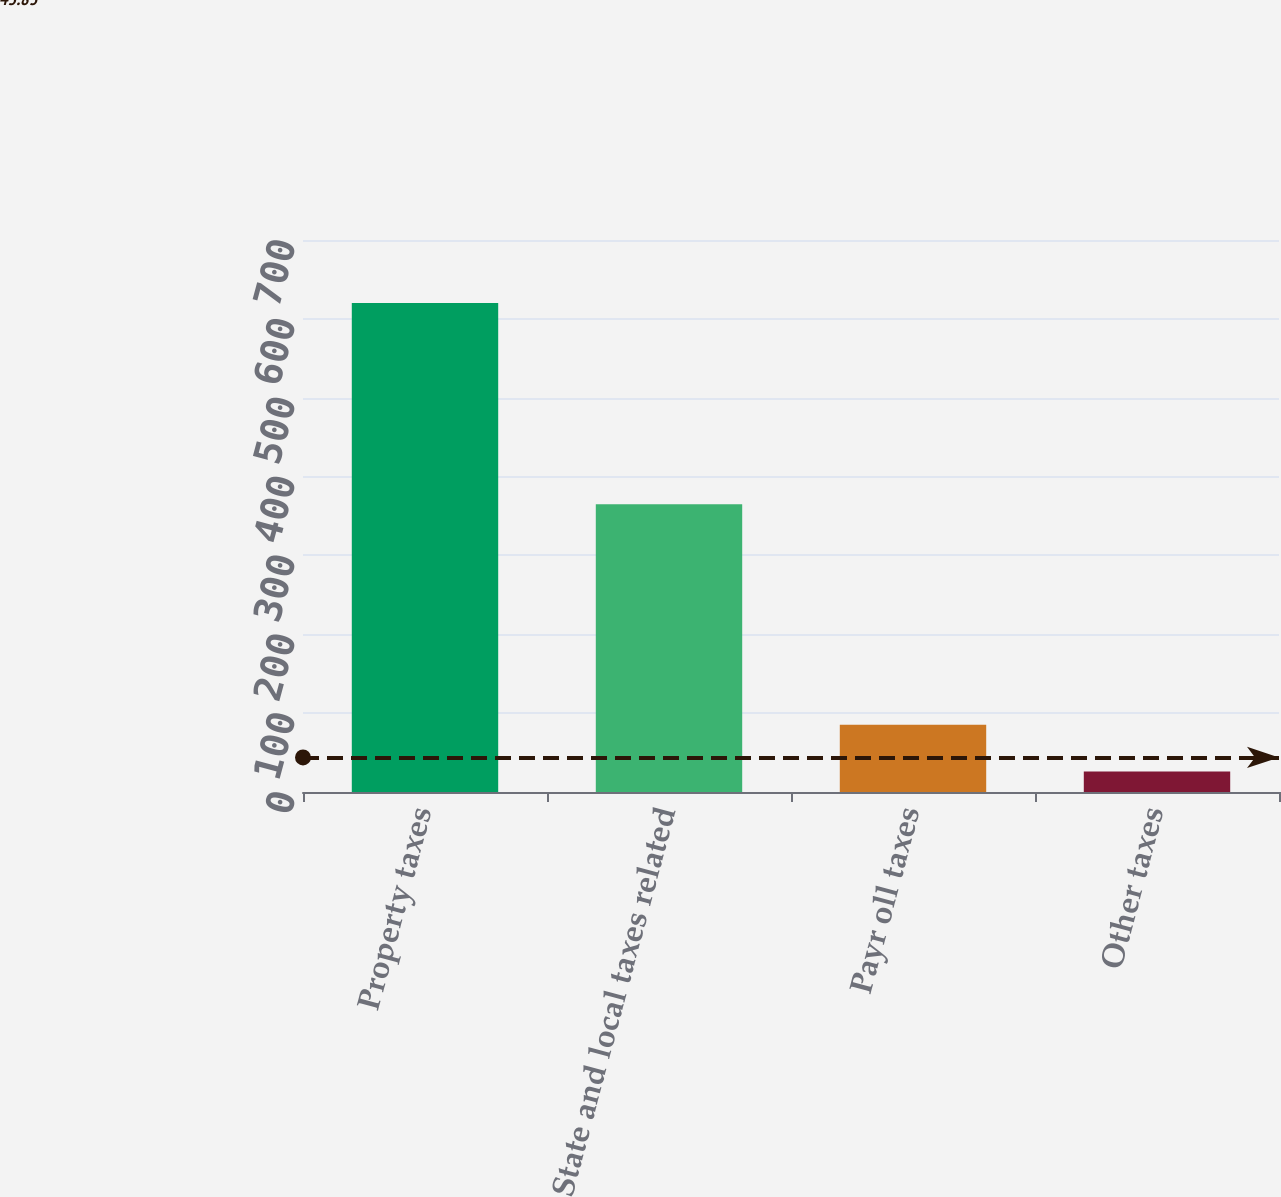Convert chart. <chart><loc_0><loc_0><loc_500><loc_500><bar_chart><fcel>Property taxes<fcel>State and local taxes related<fcel>Payr oll taxes<fcel>Other taxes<nl><fcel>620<fcel>365<fcel>85.4<fcel>26<nl></chart> 